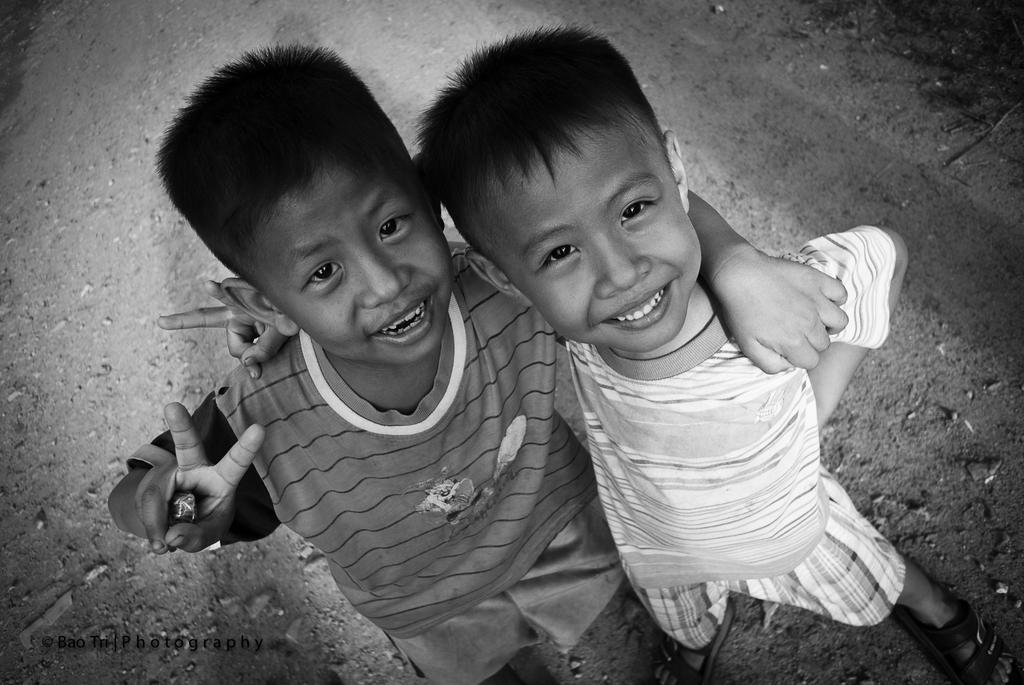How many children are in the image? There are two children in the foreground of the image. What are the children doing in the image? The children are standing and smiling. What is at the bottom of the image? There is a walkway at the bottom of the image. What type of pie is being shared between the children in the image? There is no pie present in the image; the children are simply standing and smiling. 